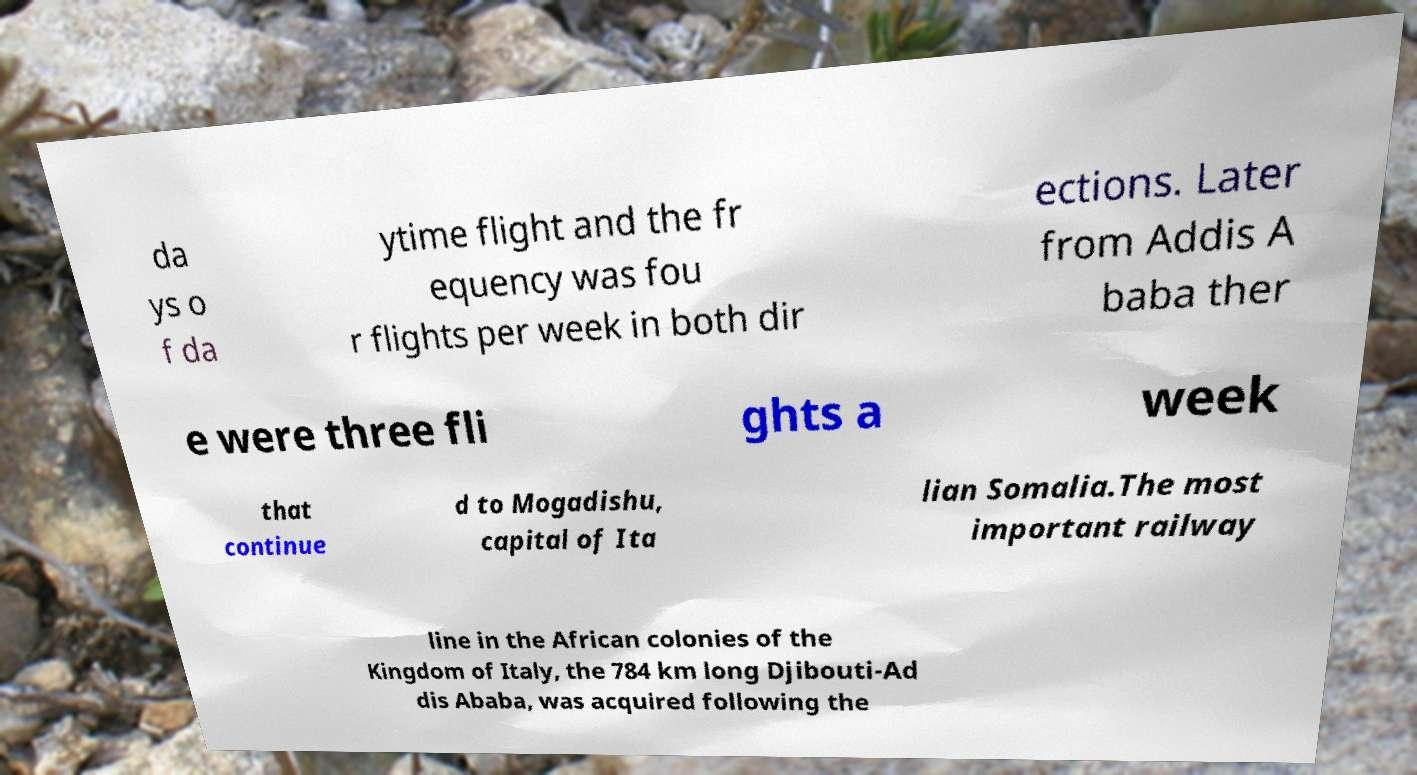Please identify and transcribe the text found in this image. da ys o f da ytime flight and the fr equency was fou r flights per week in both dir ections. Later from Addis A baba ther e were three fli ghts a week that continue d to Mogadishu, capital of Ita lian Somalia.The most important railway line in the African colonies of the Kingdom of Italy, the 784 km long Djibouti-Ad dis Ababa, was acquired following the 